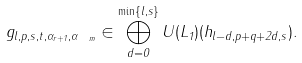<formula> <loc_0><loc_0><loc_500><loc_500>g _ { l , p , s , t , \alpha _ { r + 1 } , \alpha _ { \ m } } \in \bigoplus _ { d = 0 } ^ { \min \{ l , s \} } U ( L _ { 1 } ) ( h _ { l - d , p + q + 2 d , s } ) .</formula> 